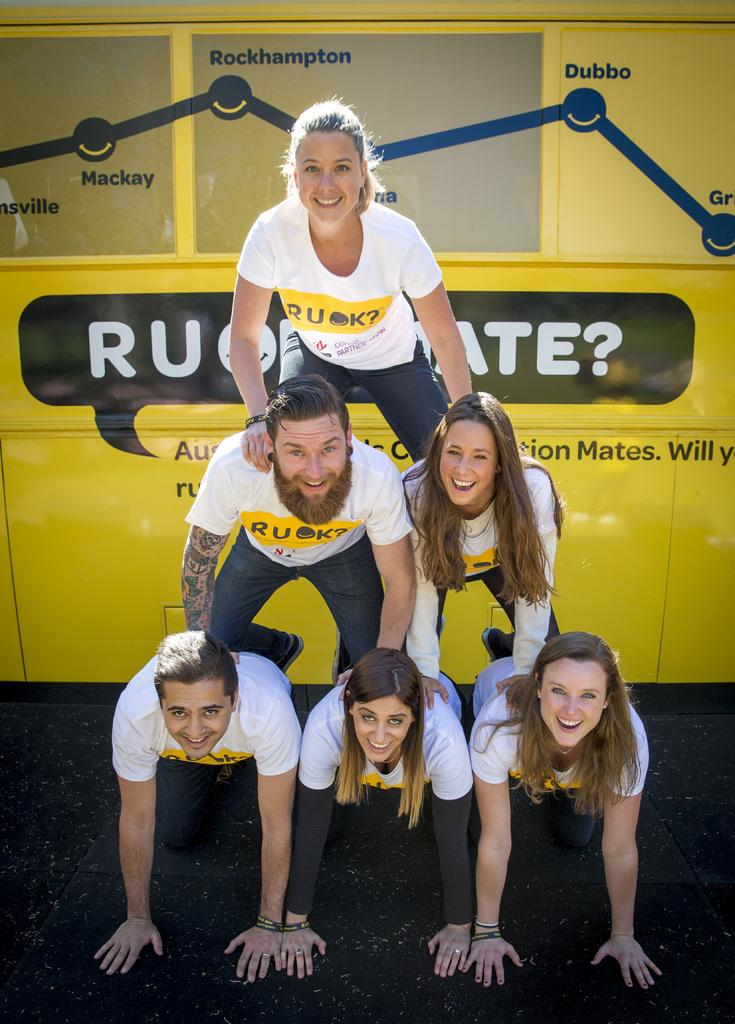<image>
Present a compact description of the photo's key features. A group of people are forming a pyramid in front of a yellow object with the word Rockhampton above them. 